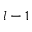Convert formula to latex. <formula><loc_0><loc_0><loc_500><loc_500>l - 1</formula> 